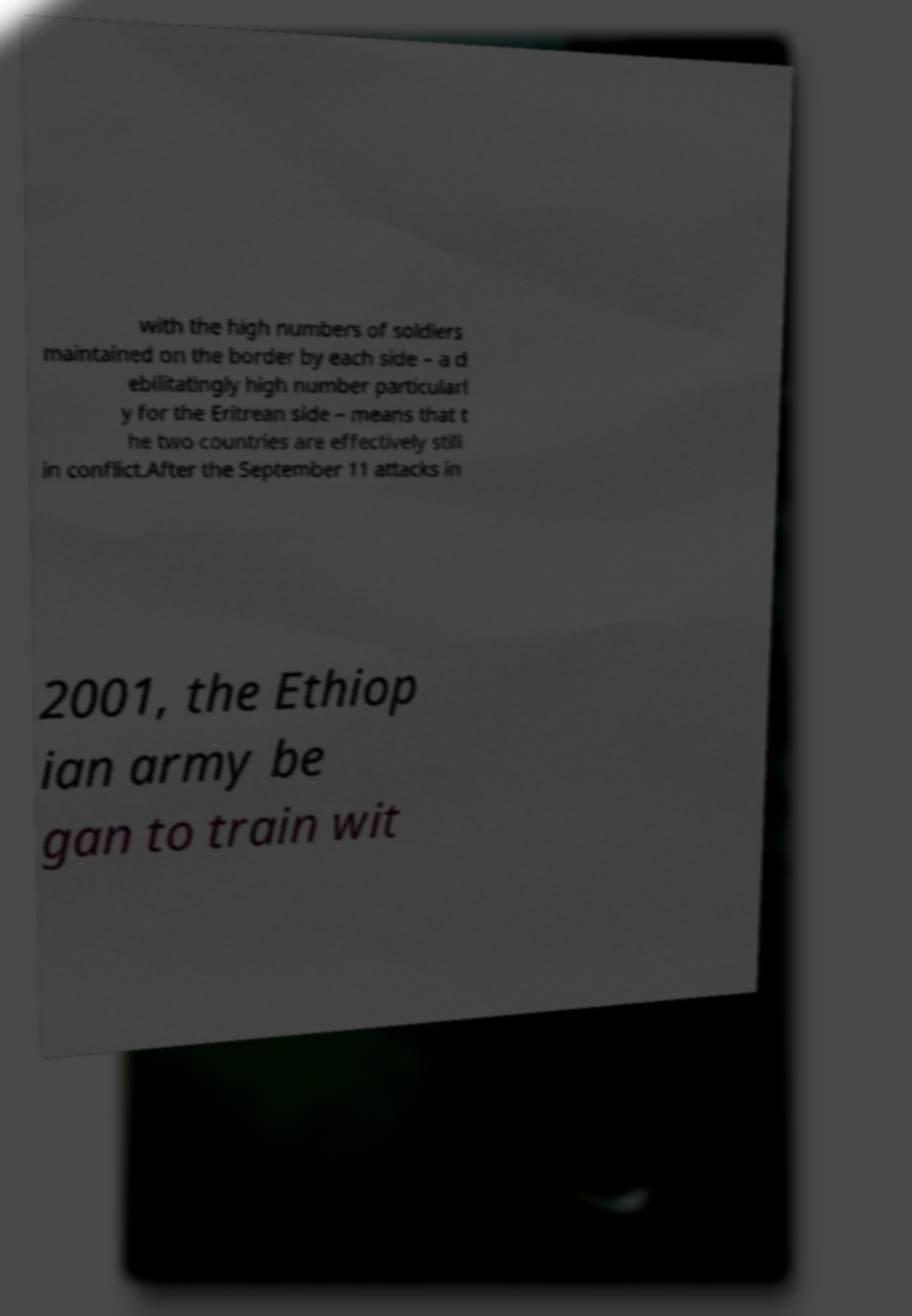What messages or text are displayed in this image? I need them in a readable, typed format. with the high numbers of soldiers maintained on the border by each side – a d ebilitatingly high number particularl y for the Eritrean side – means that t he two countries are effectively still in conflict.After the September 11 attacks in 2001, the Ethiop ian army be gan to train wit 